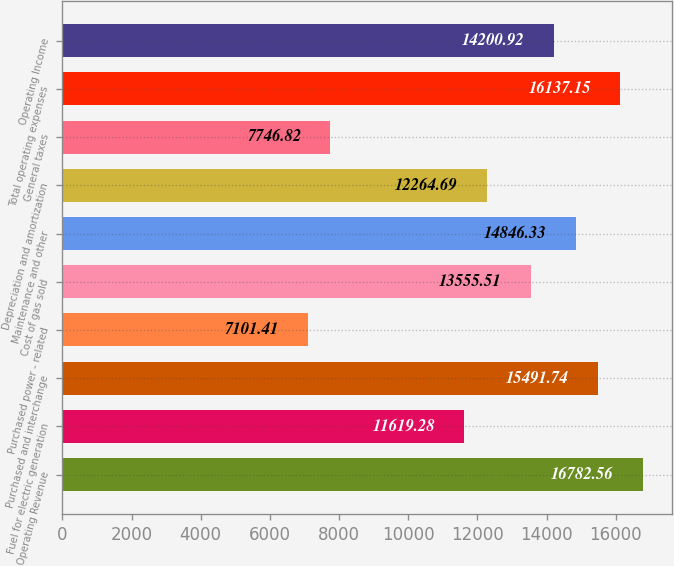Convert chart. <chart><loc_0><loc_0><loc_500><loc_500><bar_chart><fcel>Operating Revenue<fcel>Fuel for electric generation<fcel>Purchased and interchange<fcel>Purchased power - related<fcel>Cost of gas sold<fcel>Maintenance and other<fcel>Depreciation and amortization<fcel>General taxes<fcel>Total operating expenses<fcel>Operating Income<nl><fcel>16782.6<fcel>11619.3<fcel>15491.7<fcel>7101.41<fcel>13555.5<fcel>14846.3<fcel>12264.7<fcel>7746.82<fcel>16137.1<fcel>14200.9<nl></chart> 